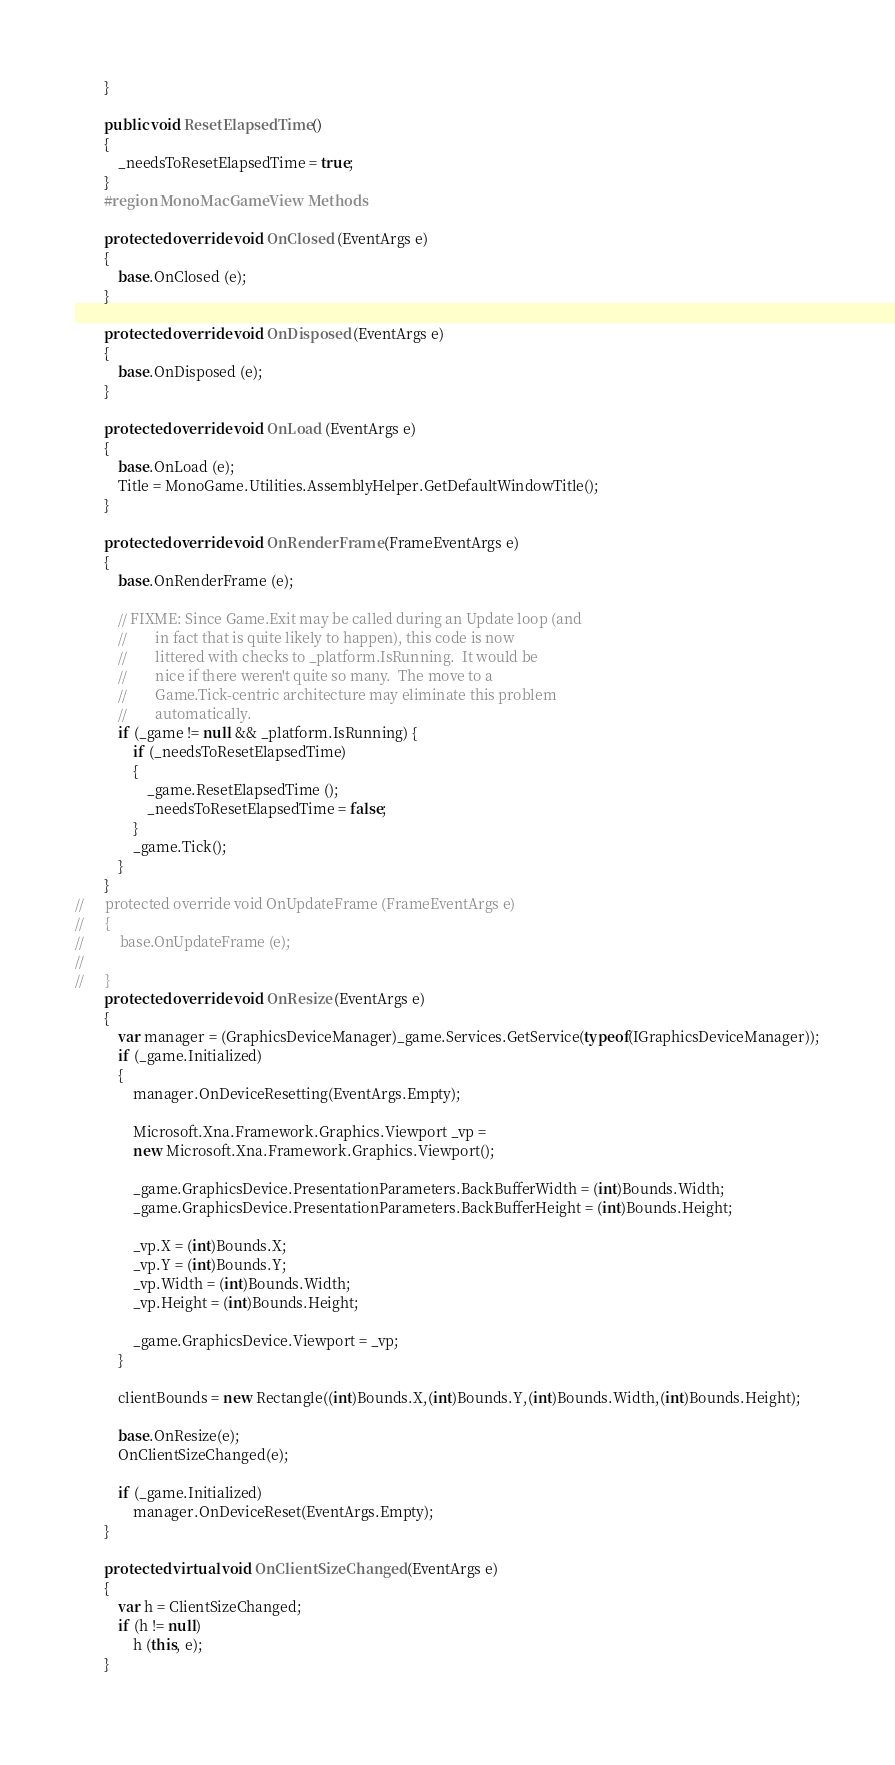<code> <loc_0><loc_0><loc_500><loc_500><_C#_>		}

		public void ResetElapsedTime ()
		{
			_needsToResetElapsedTime = true;
		}
		#region MonoMacGameView Methods

		protected override void OnClosed (EventArgs e)
		{
			base.OnClosed (e);
		}

		protected override void OnDisposed (EventArgs e)
		{
			base.OnDisposed (e);
		}

		protected override void OnLoad (EventArgs e)
		{
			base.OnLoad (e);
			Title = MonoGame.Utilities.AssemblyHelper.GetDefaultWindowTitle();
		}

		protected override void OnRenderFrame (FrameEventArgs e)
		{
			base.OnRenderFrame (e);

            // FIXME: Since Game.Exit may be called during an Update loop (and
            //        in fact that is quite likely to happen), this code is now
            //        littered with checks to _platform.IsRunning.  It would be
            //        nice if there weren't quite so many.  The move to a
            //        Game.Tick-centric architecture may eliminate this problem
            //        automatically.
			if (_game != null && _platform.IsRunning) {
                if (_needsToResetElapsedTime) 
                {
                    _game.ResetElapsedTime ();
					_needsToResetElapsedTime = false;
                }
				_game.Tick();
			}
		}
//		protected override void OnUpdateFrame (FrameEventArgs e)
//		{
//			base.OnUpdateFrame (e);
//
//		}
		protected override void OnResize (EventArgs e)
		{
            var manager = (GraphicsDeviceManager)_game.Services.GetService(typeof(IGraphicsDeviceManager));
            if (_game.Initialized)
            {
    			manager.OnDeviceResetting(EventArgs.Empty);
    			
    			Microsoft.Xna.Framework.Graphics.Viewport _vp =
    			new Microsoft.Xna.Framework.Graphics.Viewport();
    			
    			_game.GraphicsDevice.PresentationParameters.BackBufferWidth = (int)Bounds.Width;
    			_game.GraphicsDevice.PresentationParameters.BackBufferHeight = (int)Bounds.Height;

    			_vp.X = (int)Bounds.X;
    			_vp.Y = (int)Bounds.Y;
    			_vp.Width = (int)Bounds.Width;
    			_vp.Height = (int)Bounds.Height;

    			_game.GraphicsDevice.Viewport = _vp;
            }
			
			clientBounds = new Rectangle((int)Bounds.X,(int)Bounds.Y,(int)Bounds.Width,(int)Bounds.Height);
			
			base.OnResize(e);
			OnClientSizeChanged(e);

            if (_game.Initialized)
    			manager.OnDeviceReset(EventArgs.Empty);
		}
		
		protected virtual void OnClientSizeChanged (EventArgs e)
		{
			var h = ClientSizeChanged;
			if (h != null)
				h (this, e);
		}
		</code> 